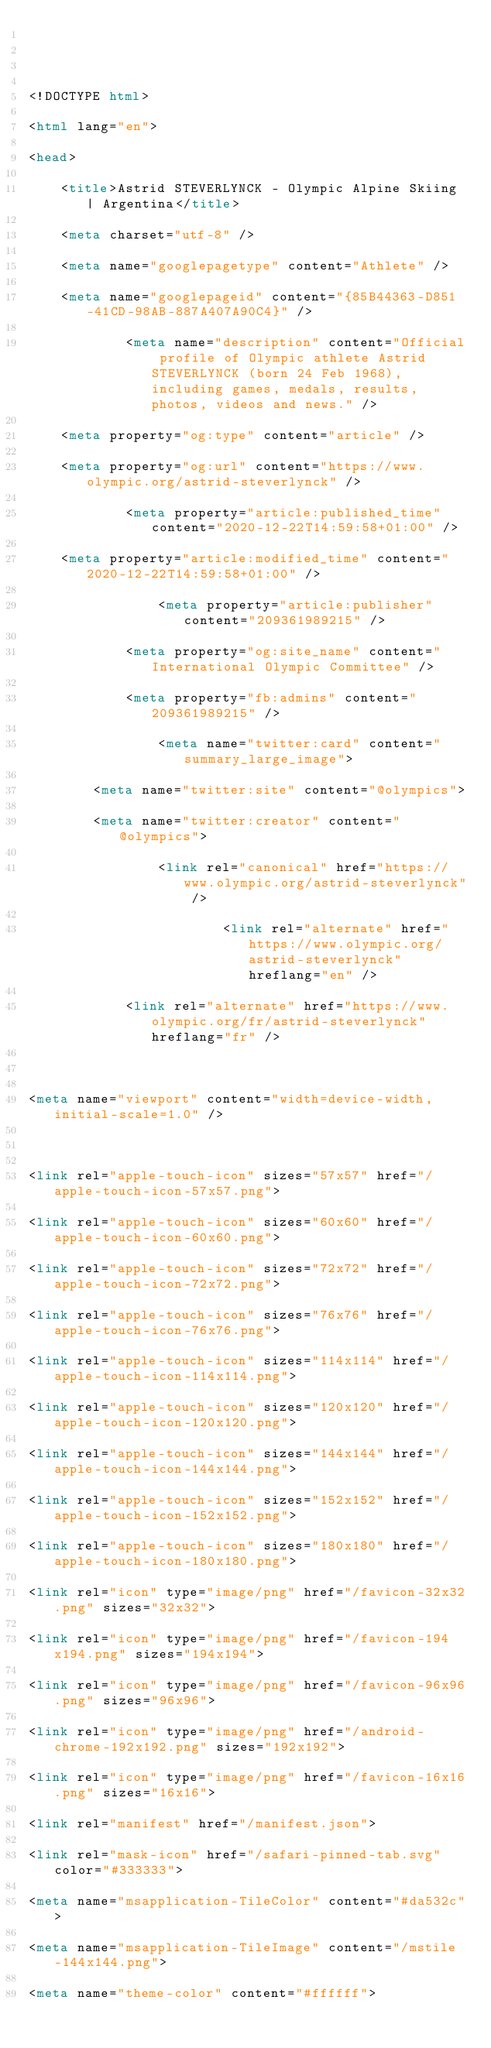Convert code to text. <code><loc_0><loc_0><loc_500><loc_500><_HTML_>

<!DOCTYPE html>
<html lang="en">
<head>
    <title>Astrid STEVERLYNCK - Olympic Alpine Skiing | Argentina</title>
    <meta charset="utf-8" />
    <meta name="googlepagetype" content="Athlete" />
    <meta name="googlepageid" content="{85B44363-D851-41CD-98AB-887A407A90C4}" />
            <meta name="description" content="Official profile of Olympic athlete Astrid STEVERLYNCK (born 24 Feb 1968), including games, medals, results, photos, videos and news." />
    <meta property="og:type" content="article" />
    <meta property="og:url" content="https://www.olympic.org/astrid-steverlynck" />
            <meta property="article:published_time" content="2020-12-22T14:59:58+01:00" />
    <meta property="article:modified_time" content="2020-12-22T14:59:58+01:00" />
                <meta property="article:publisher" content="209361989215" />
            <meta property="og:site_name" content="International Olympic Committee" />
            <meta property="fb:admins" content="209361989215" />
                <meta name="twitter:card" content="summary_large_image">
        <meta name="twitter:site" content="@olympics">
        <meta name="twitter:creator" content="@olympics">
                <link rel="canonical" href="https://www.olympic.org/astrid-steverlynck" />
                        <link rel="alternate" href="https://www.olympic.org/astrid-steverlynck" hreflang="en" />
            <link rel="alternate" href="https://www.olympic.org/fr/astrid-steverlynck" hreflang="fr" />
    
<meta name="viewport" content="width=device-width, initial-scale=1.0" />

<link rel="apple-touch-icon" sizes="57x57" href="/apple-touch-icon-57x57.png">
<link rel="apple-touch-icon" sizes="60x60" href="/apple-touch-icon-60x60.png">
<link rel="apple-touch-icon" sizes="72x72" href="/apple-touch-icon-72x72.png">
<link rel="apple-touch-icon" sizes="76x76" href="/apple-touch-icon-76x76.png">
<link rel="apple-touch-icon" sizes="114x114" href="/apple-touch-icon-114x114.png">
<link rel="apple-touch-icon" sizes="120x120" href="/apple-touch-icon-120x120.png">
<link rel="apple-touch-icon" sizes="144x144" href="/apple-touch-icon-144x144.png">
<link rel="apple-touch-icon" sizes="152x152" href="/apple-touch-icon-152x152.png">
<link rel="apple-touch-icon" sizes="180x180" href="/apple-touch-icon-180x180.png">
<link rel="icon" type="image/png" href="/favicon-32x32.png" sizes="32x32">
<link rel="icon" type="image/png" href="/favicon-194x194.png" sizes="194x194">
<link rel="icon" type="image/png" href="/favicon-96x96.png" sizes="96x96">
<link rel="icon" type="image/png" href="/android-chrome-192x192.png" sizes="192x192">
<link rel="icon" type="image/png" href="/favicon-16x16.png" sizes="16x16">
<link rel="manifest" href="/manifest.json">
<link rel="mask-icon" href="/safari-pinned-tab.svg" color="#333333">
<meta name="msapplication-TileColor" content="#da532c">
<meta name="msapplication-TileImage" content="/mstile-144x144.png">
<meta name="theme-color" content="#ffffff"></code> 